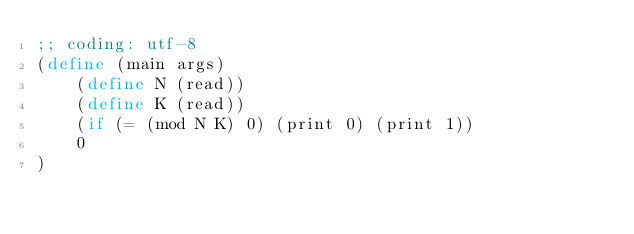<code> <loc_0><loc_0><loc_500><loc_500><_Scheme_>;; coding: utf-8
(define (main args)
    (define N (read))
    (define K (read))
    (if (= (mod N K) 0) (print 0) (print 1))
    0
)</code> 